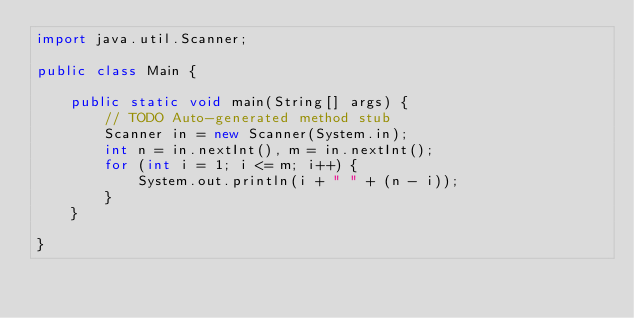<code> <loc_0><loc_0><loc_500><loc_500><_Java_>import java.util.Scanner;

public class Main {

    public static void main(String[] args) {
        // TODO Auto-generated method stub
        Scanner in = new Scanner(System.in);
        int n = in.nextInt(), m = in.nextInt();
        for (int i = 1; i <= m; i++) {
            System.out.println(i + " " + (n - i));
        }
    }

}</code> 